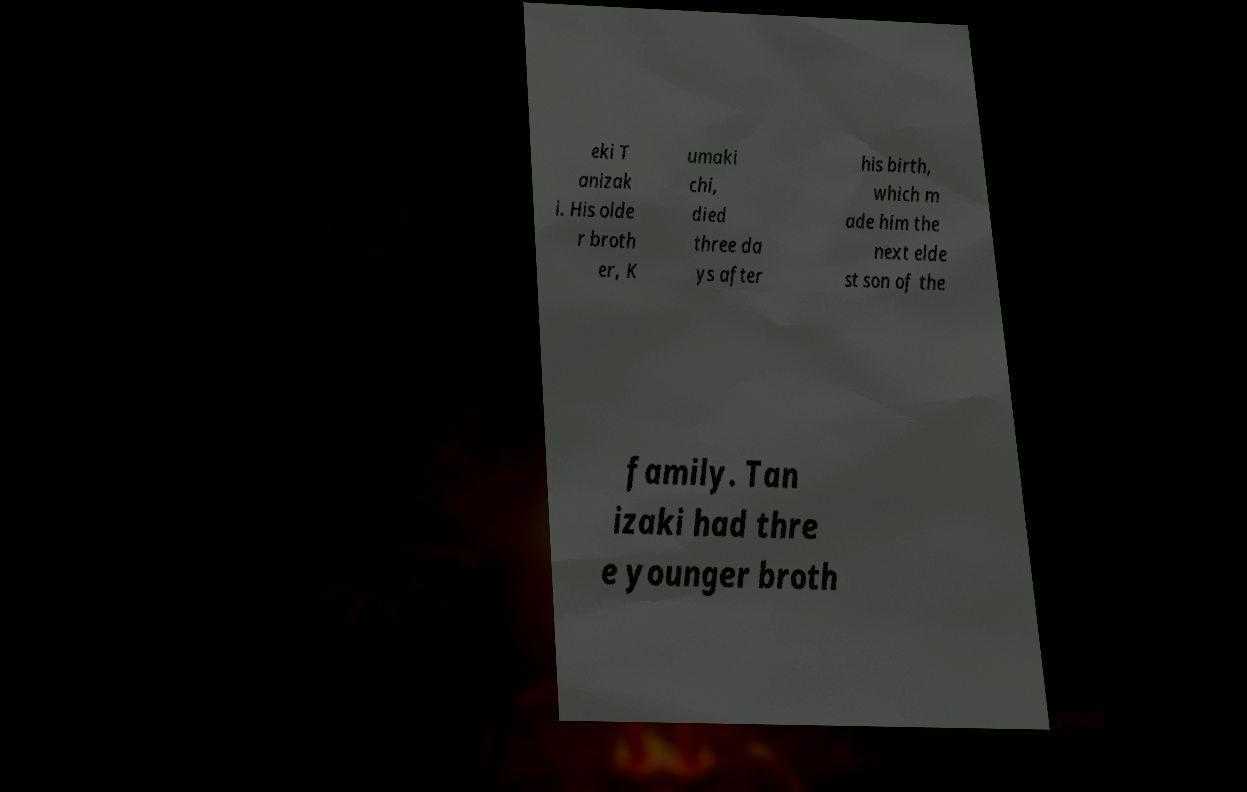I need the written content from this picture converted into text. Can you do that? eki T anizak i. His olde r broth er, K umaki chi, died three da ys after his birth, which m ade him the next elde st son of the family. Tan izaki had thre e younger broth 